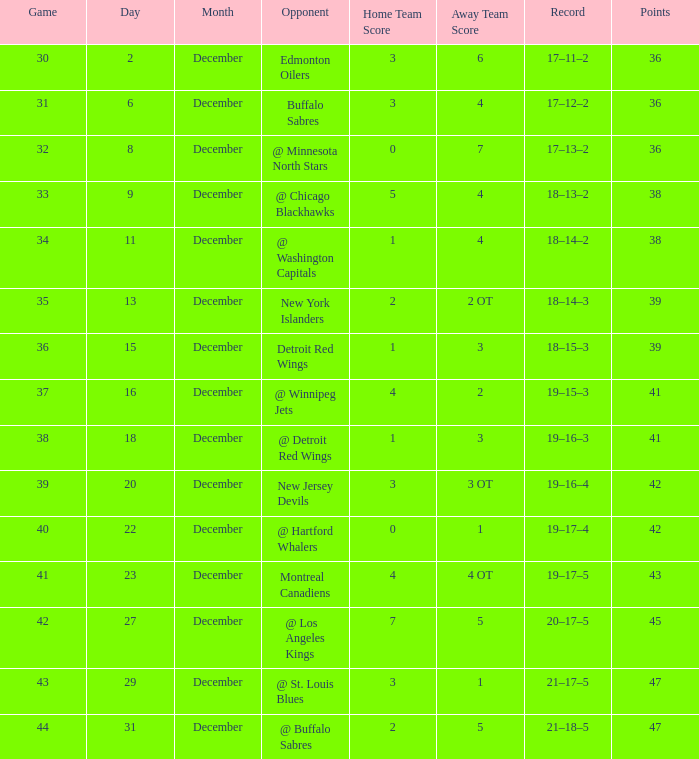After december 29 what is the score? 2–5. 